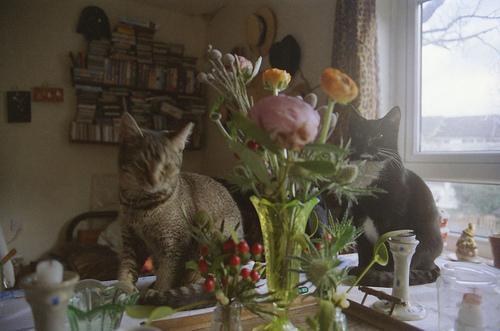How many cats are there?
Give a very brief answer. 2. 